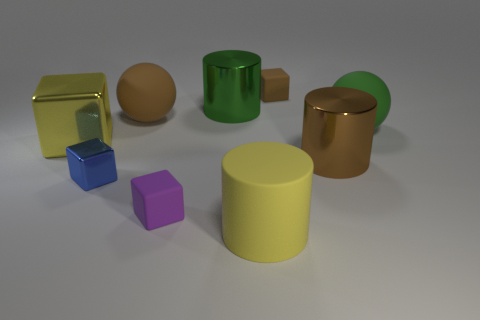What can the arrangement of these objects suggest? The arrangement seems intentional, almost like a still life composition, perhaps suggesting concepts of diversity, harmony among different shapes, or an aesthetic display of basic geometrical forms. 